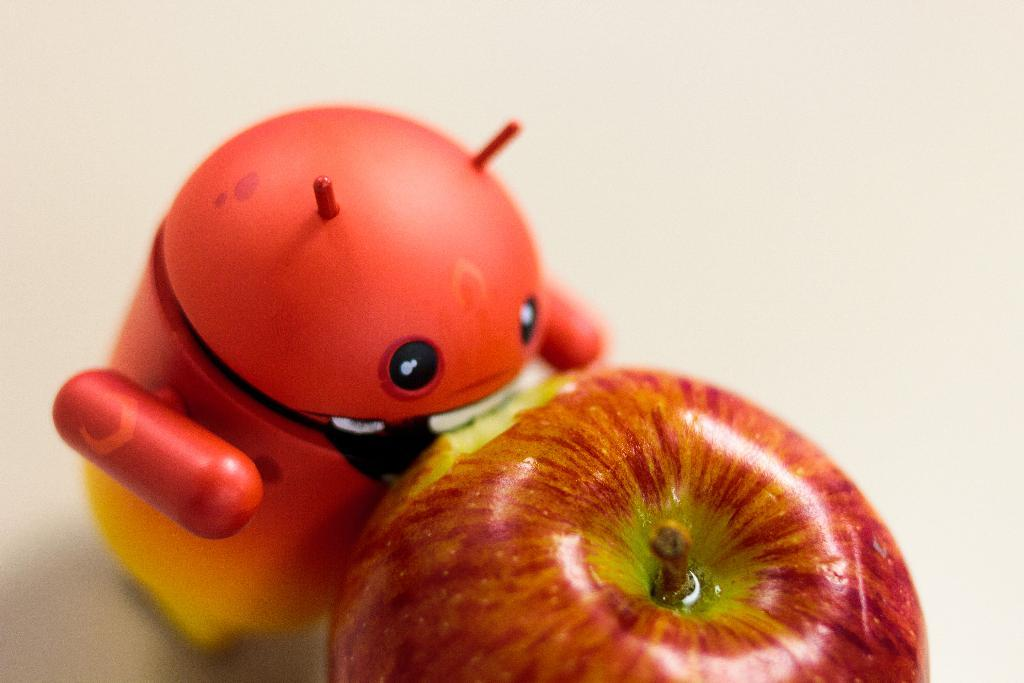What is located at the bottom of the image? There is an apple at the bottom of the image. What other object is near the apple? There is a toy beside the apple. What is the color of the surface on which the apple and toy are placed? Both the apple and the toy are placed on a white surface. What type of hat is the bird wearing in the image? There is no bird or hat present in the image. 